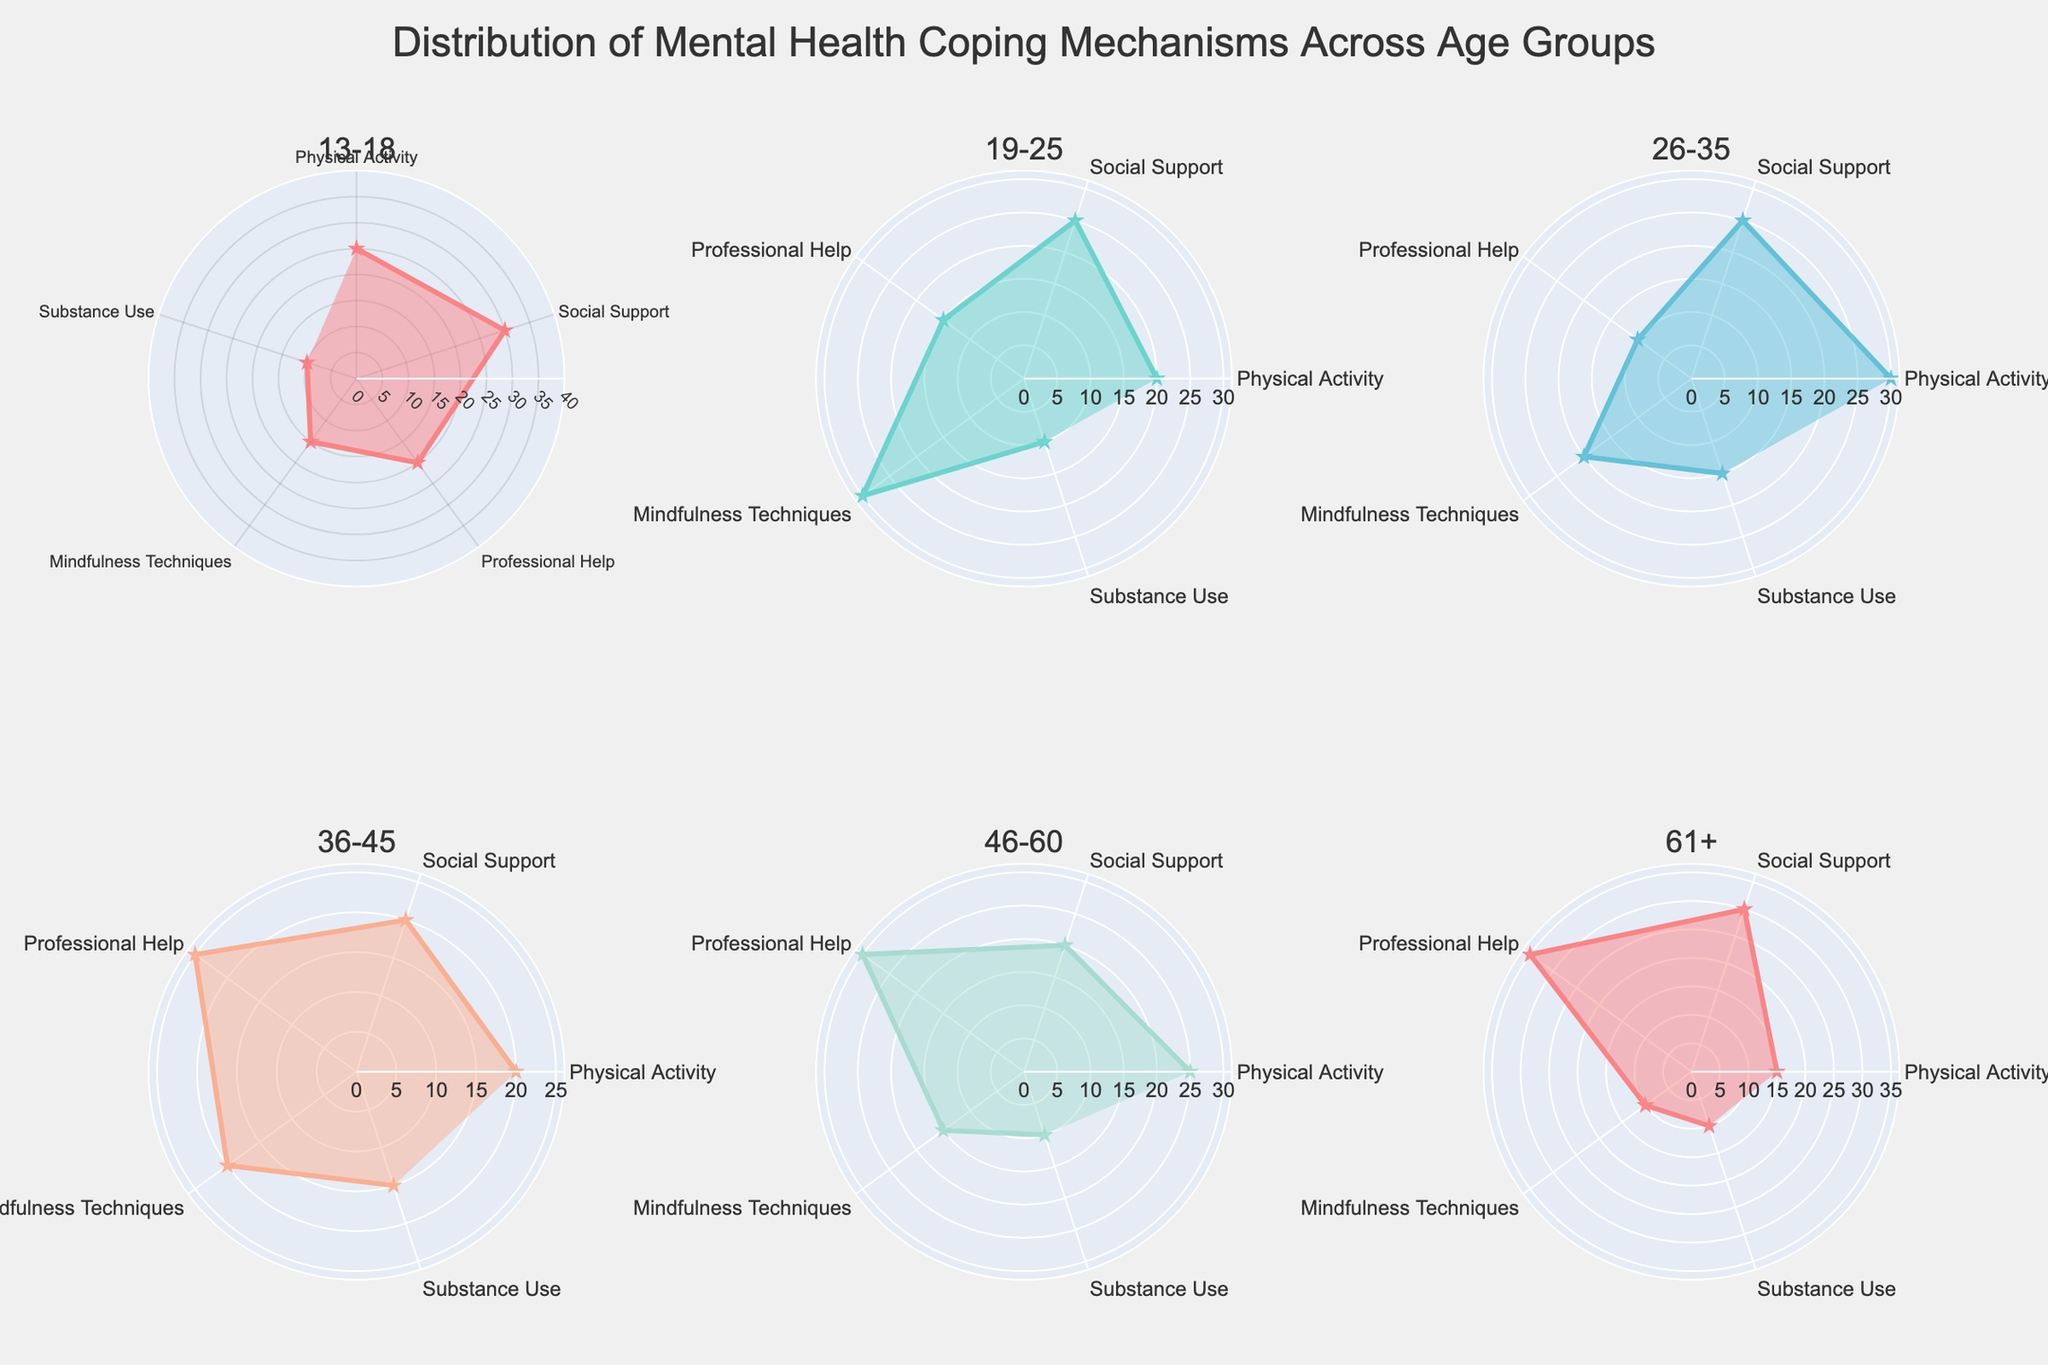Which coping mechanism is most used by the 13-18 age group? By examining the plot corresponding to the 13-18 age group, observe which coping mechanism extends furthest from the center, as this represents the highest percentage.
Answer: Social Support What is the total percentage of the 46-60 age group using Physical Activity and Social Support? Look at the 46-60 subplot and sum the percentages for Physical Activity and Social Support.
Answer: 45% Which age group has the highest percentage for Professional Help? Compare the percentages for Professional Help across all the subplots and identify the age group with the highest value.
Answer: 61+ How does the usage of Mindfulness Techniques compare between the 19-25 and 26-35 age groups? Check the subplots for both the 19-25 and 26-35 age groups and compare the percentages for Mindfulness Techniques.
Answer: Higher in 19-25 What coping mechanism has the lowest percentage in the 61+ age group? Find the coping mechanism with the shortest line in the 61+ subplot.
Answer: Mindfulness Techniques Which two age groups show the same percentage for Substance Use? Compare percentages for Substance Use across all subplots and identify any two age groups with equal values.
Answer: 13-18 and 19-25 What's the range of percentages for Social Support across all age groups? Identify the minimum and maximum percentages for Social Support in all subplots and compute their difference.
Answer: 10% Is Substance Use more commonly reported in the 26-35 age group or the 36-45 age group? Compare the values for Substance Use in the corresponding subplots and determine which age group has a higher percentage.
Answer: 26-35 How many age groups report Mindfulness Techniques as being used by at least 20% of individuals? Count the subplots where the percentage for Mindfulness Techniques is 20% or higher.
Answer: 3 